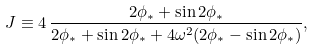<formula> <loc_0><loc_0><loc_500><loc_500>J \equiv 4 \, \frac { 2 \phi _ { * } + \sin 2 \phi _ { * } } { 2 \phi _ { * } + \sin 2 \phi _ { * } + 4 \omega ^ { 2 } ( 2 \phi _ { * } - \sin 2 \phi _ { * } ) } ,</formula> 